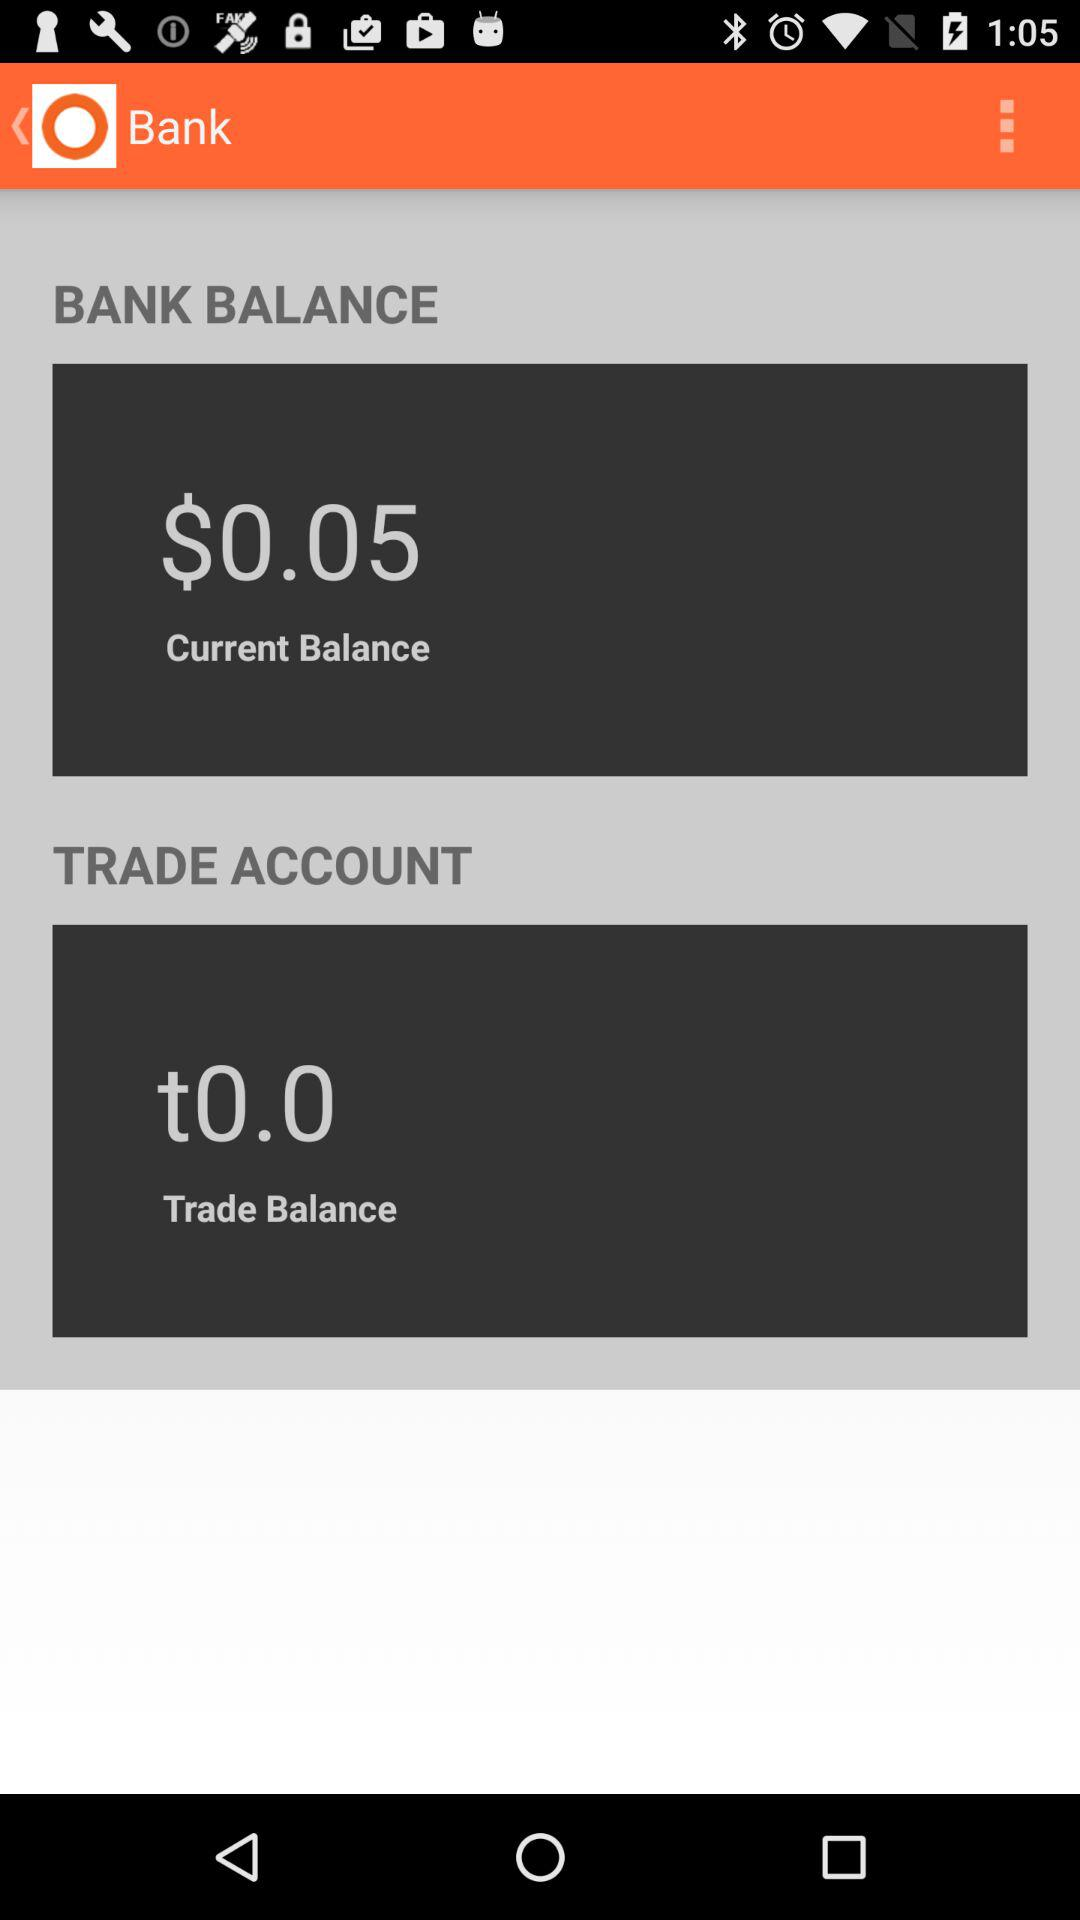What is the current balance in the bank? The current balance is $0.05. 